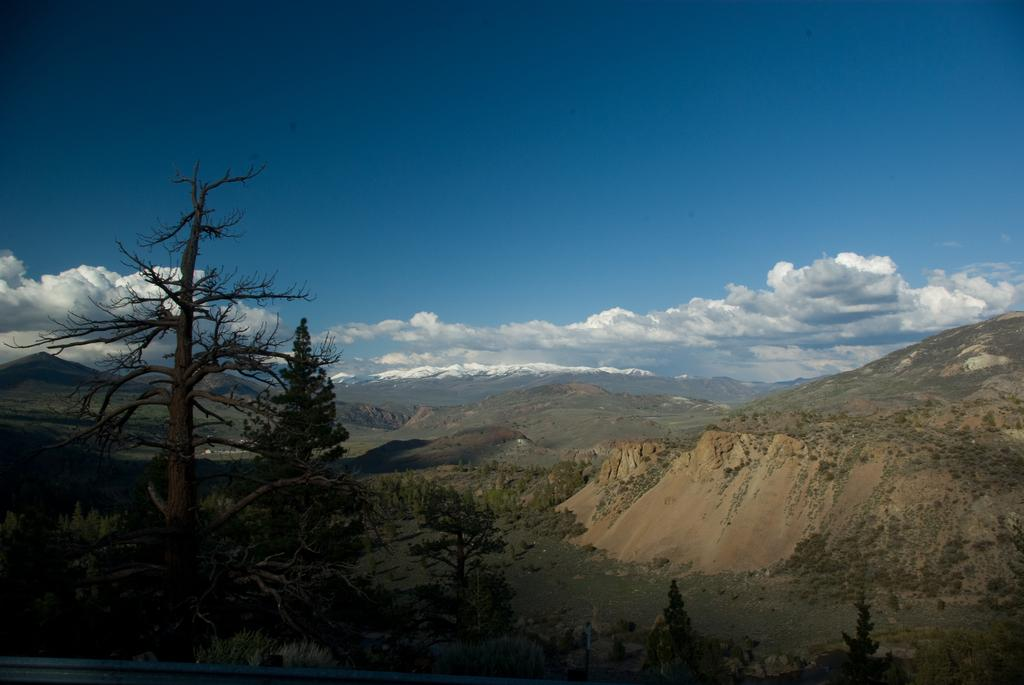What type of vegetation can be seen in the image? There are trees in the image. What geographical features are present in the image? There are hills in the image. What type of ground cover is visible in the image? There is grass in the image. What can be seen in the background of the image? The sky is visible in the background of the image. What is the condition of the sky in the image? Clouds are present in the sky. Where is the girl standing with her ring in the image? There is no girl or ring present in the image. What type of mailbox can be seen near the trees in the image? There is no mailbox present in the image. 